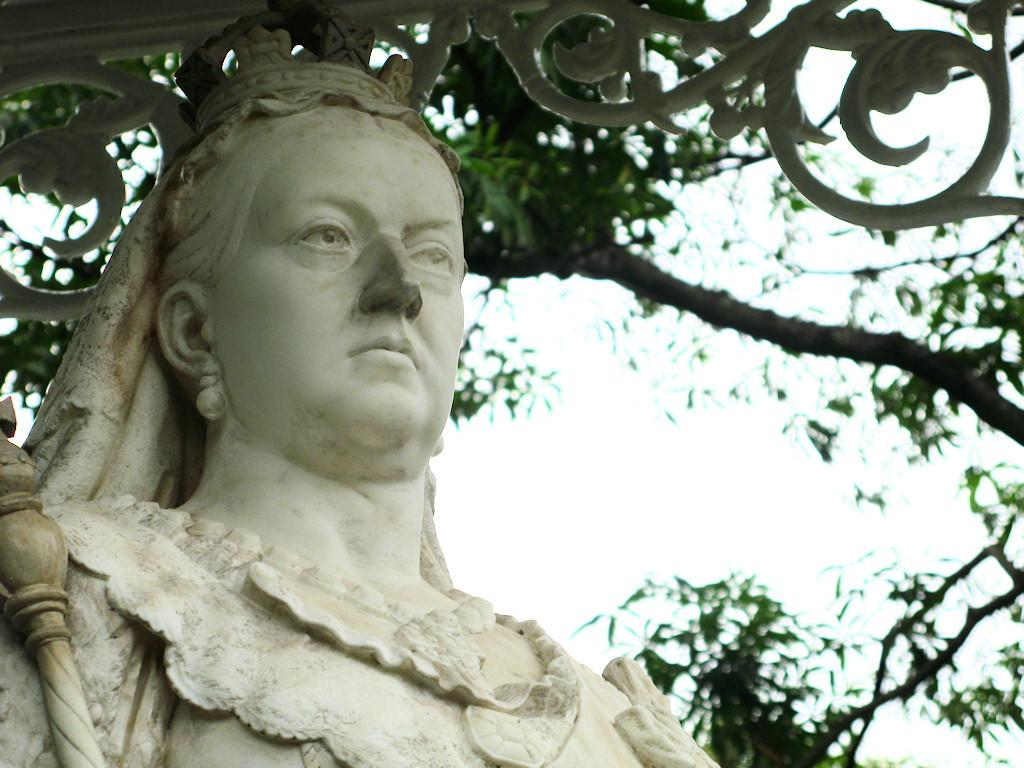What is the main subject of the image? There is a white color sculpture in the image. What can be seen in the background of the image? There are leaves and branches of a tree in the background of the image. How would you describe the quality of the image in the background? The image is slightly blurry in the background. Can you tell me how many legs the mask has in the image? There is no mask present in the image. 